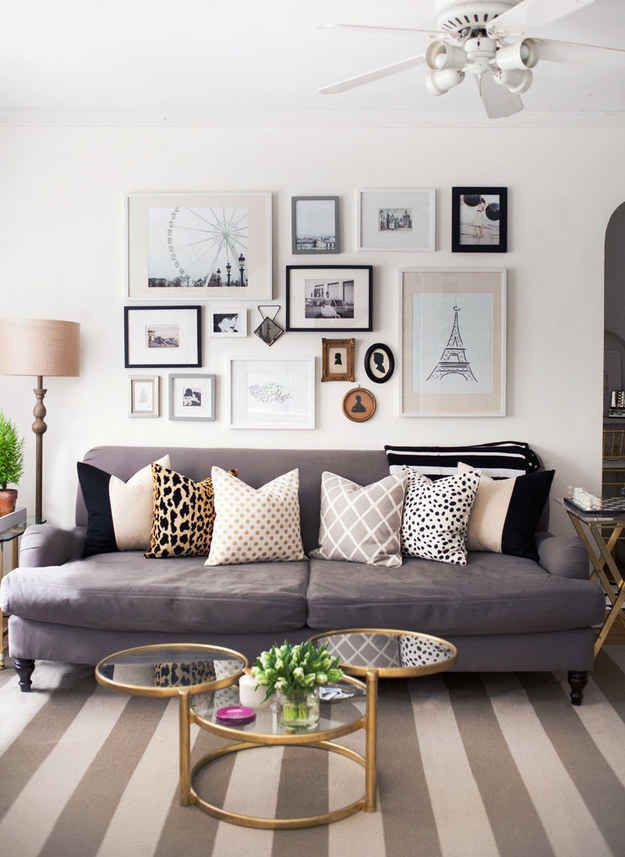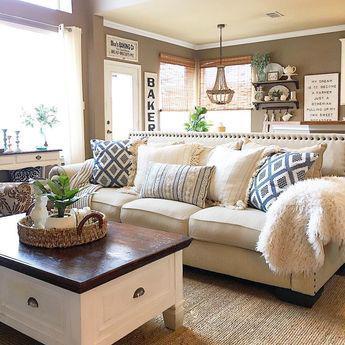The first image is the image on the left, the second image is the image on the right. Examine the images to the left and right. Is the description "There is a plant on the coffee table in at least one image." accurate? Answer yes or no. Yes. The first image is the image on the left, the second image is the image on the right. Examine the images to the left and right. Is the description "In one image, a bottle and glass containing a drink are sitting near a seating area." accurate? Answer yes or no. No. 